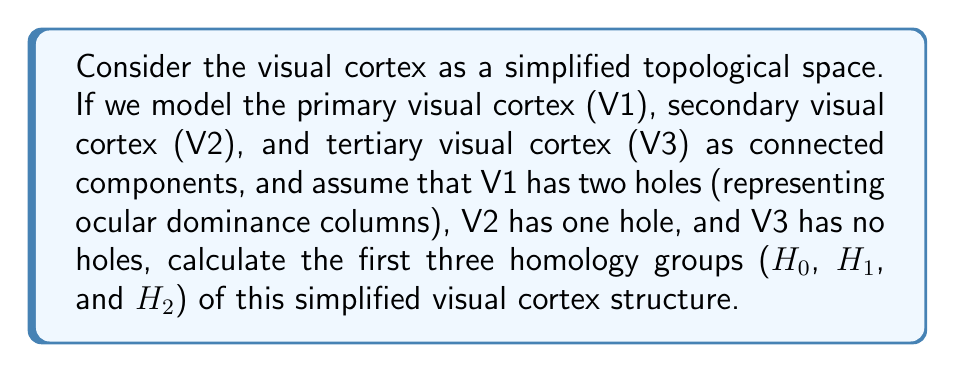Can you answer this question? To solve this problem, we need to understand the concept of homology groups and how they relate to the topological features of the simplified visual cortex structure. Let's break it down step-by-step:

1. Understand the given structure:
   - We have three connected components: V1, V2, and V3
   - V1 has two holes
   - V2 has one hole
   - V3 has no holes

2. Recall the meaning of homology groups:
   - $H_0$: represents the number of connected components
   - $H_1$: represents the number of 1-dimensional holes (loops)
   - $H_2$: represents the number of 2-dimensional holes (voids)

3. Calculate $H_0$:
   - There are 3 connected components (V1, V2, and V3)
   - Therefore, $H_0 \cong \mathbb{Z} \oplus \mathbb{Z} \oplus \mathbb{Z}$

4. Calculate $H_1$:
   - V1 has 2 holes
   - V2 has 1 hole
   - V3 has 0 holes
   - Total number of 1-dimensional holes: 2 + 1 + 0 = 3
   - Therefore, $H_1 \cong \mathbb{Z} \oplus \mathbb{Z} \oplus \mathbb{Z}$

5. Calculate $H_2$:
   - There are no 2-dimensional holes (voids) in the given structure
   - Therefore, $H_2 \cong 0$ (the trivial group)

Thus, we have calculated the first three homology groups of the simplified visual cortex structure.
Answer: $H_0 \cong \mathbb{Z} \oplus \mathbb{Z} \oplus \mathbb{Z}$
$H_1 \cong \mathbb{Z} \oplus \mathbb{Z} \oplus \mathbb{Z}$
$H_2 \cong 0$ 